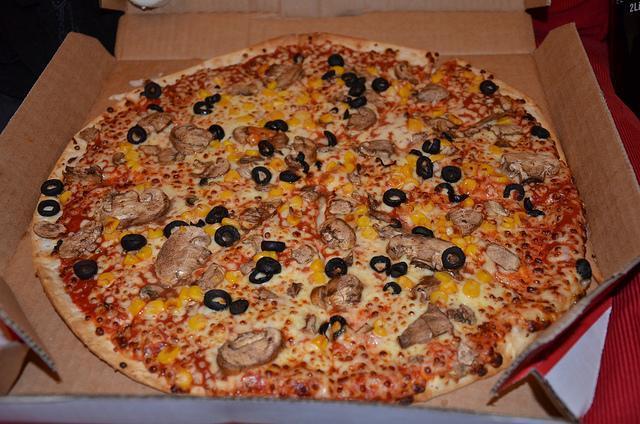How many slices are missing from the pizza?
Give a very brief answer. 0. 